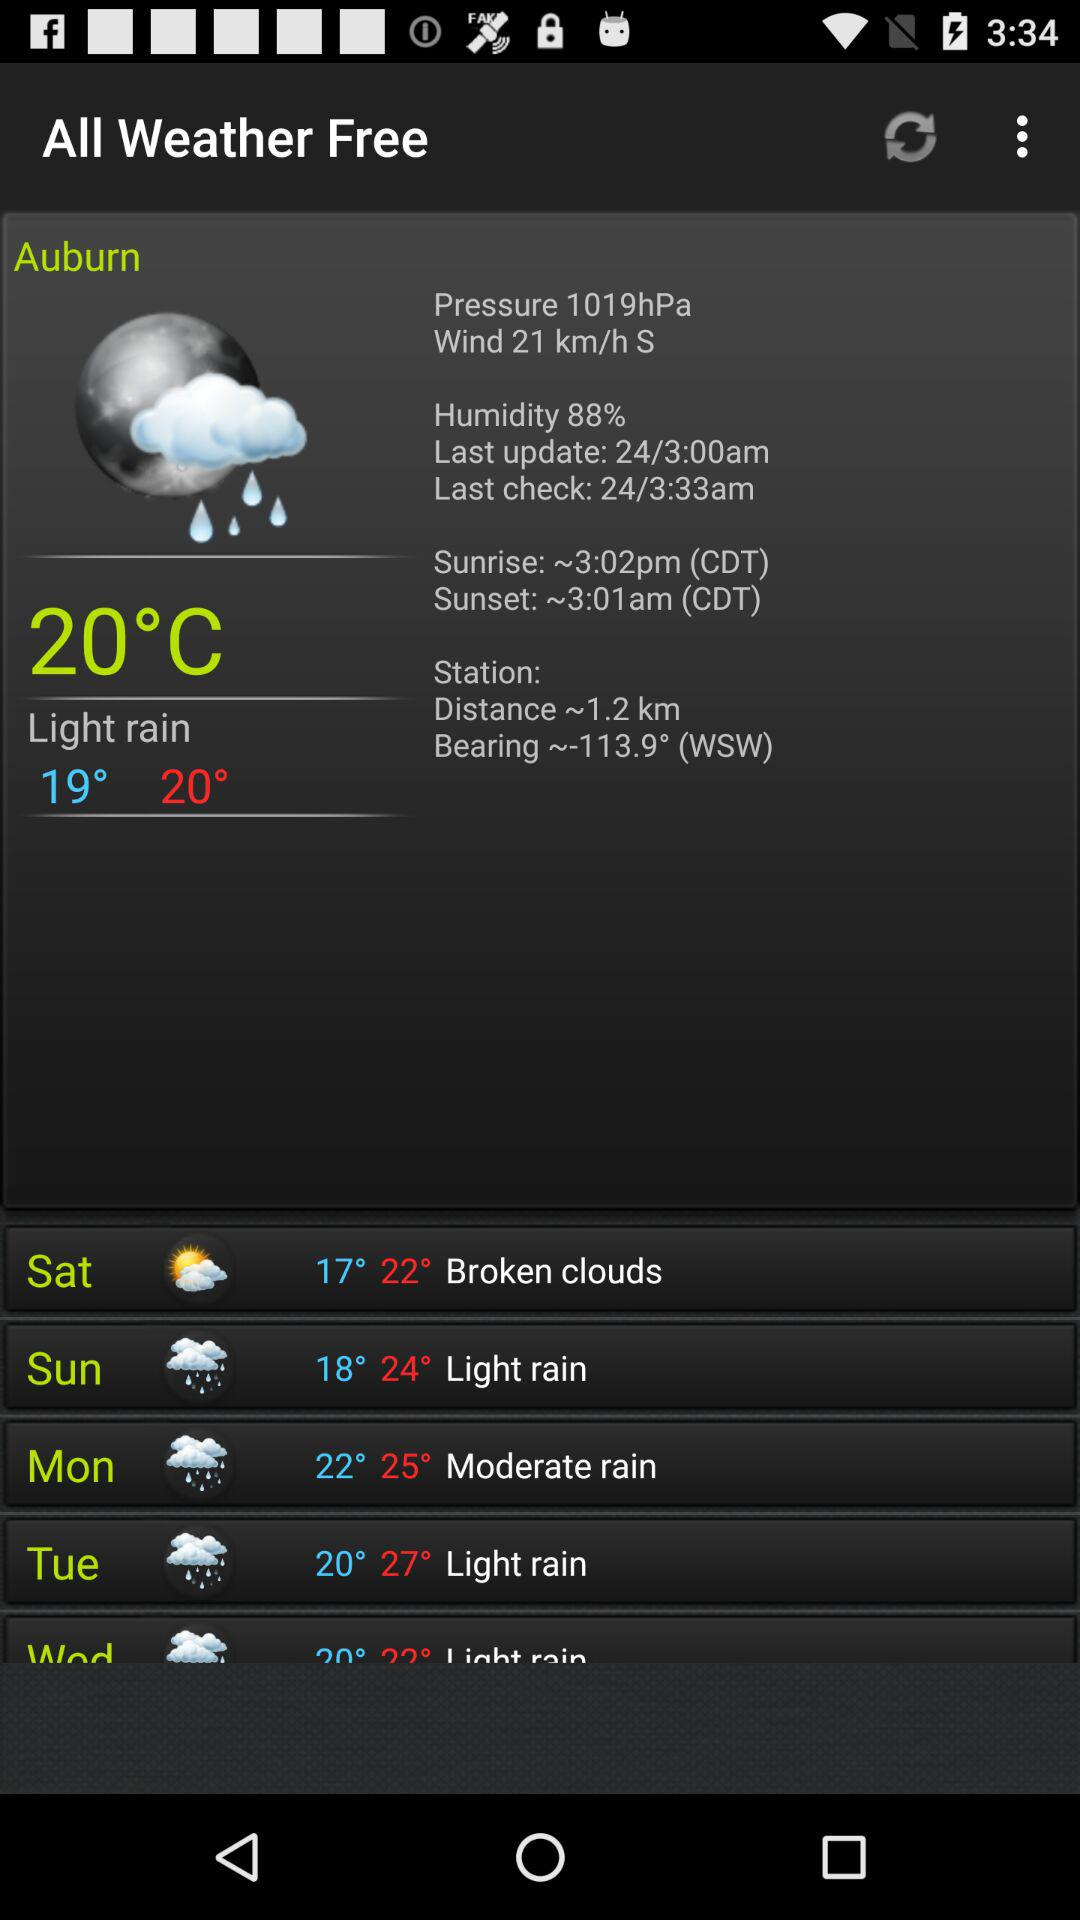What is the "Last Check" time? The time is 3:33 AM. 